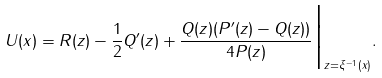<formula> <loc_0><loc_0><loc_500><loc_500>U ( x ) = R ( z ) - \frac { 1 } 2 Q ^ { \prime } ( z ) + \frac { Q ( z ) ( P ^ { \prime } ( z ) - Q ( z ) ) } { 4 P ( z ) } \Big | _ { z = \xi ^ { - 1 } ( x ) } .</formula> 